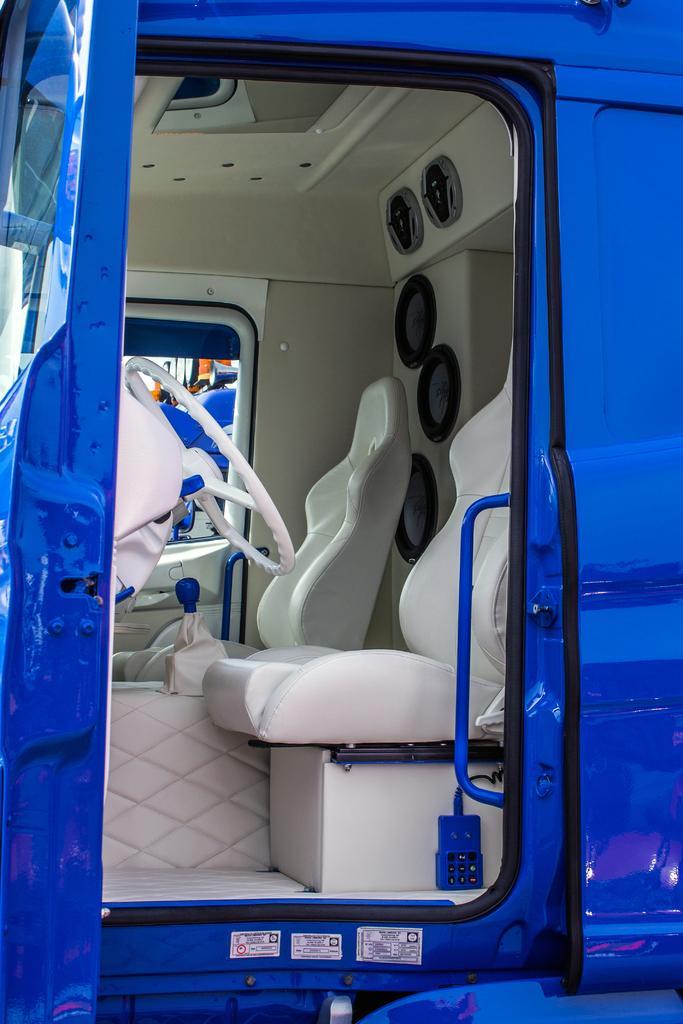Can you describe this image briefly? In this image, we can see a vehicle which is in blue color. In the vehicle, on the left side, we can see steering. On the right side, we can see two seats. At the top, we can see a roof. 